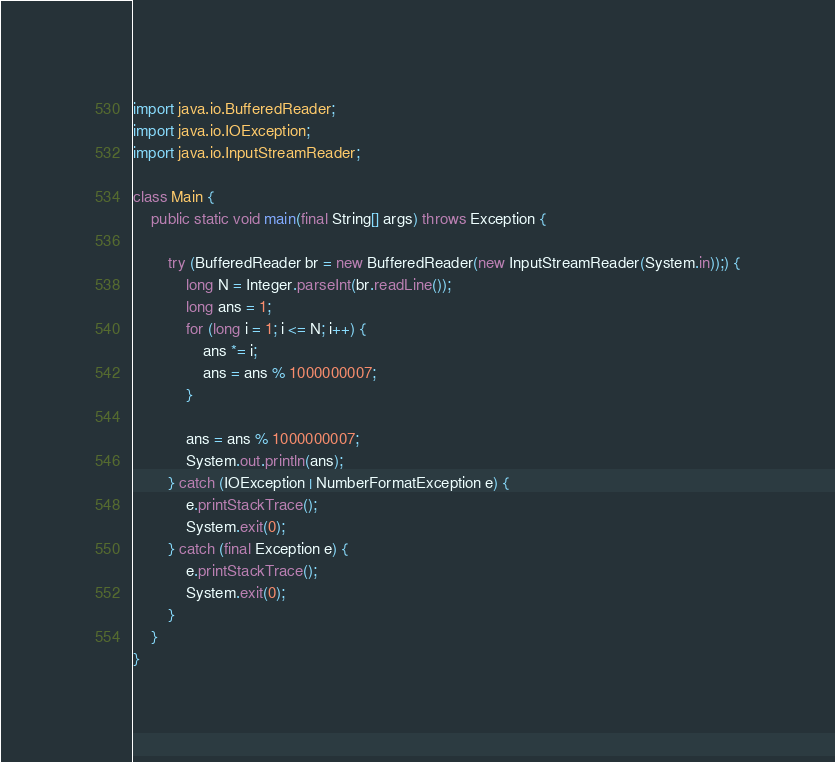<code> <loc_0><loc_0><loc_500><loc_500><_Java_>import java.io.BufferedReader;
import java.io.IOException;
import java.io.InputStreamReader;

class Main {
    public static void main(final String[] args) throws Exception {

        try (BufferedReader br = new BufferedReader(new InputStreamReader(System.in));) {
            long N = Integer.parseInt(br.readLine());
            long ans = 1;
            for (long i = 1; i <= N; i++) {
                ans *= i;
                ans = ans % 1000000007;
            }

            ans = ans % 1000000007;
            System.out.println(ans);
        } catch (IOException | NumberFormatException e) {
            e.printStackTrace();
            System.exit(0);
        } catch (final Exception e) {
            e.printStackTrace();
            System.exit(0);
        }
    }
}</code> 